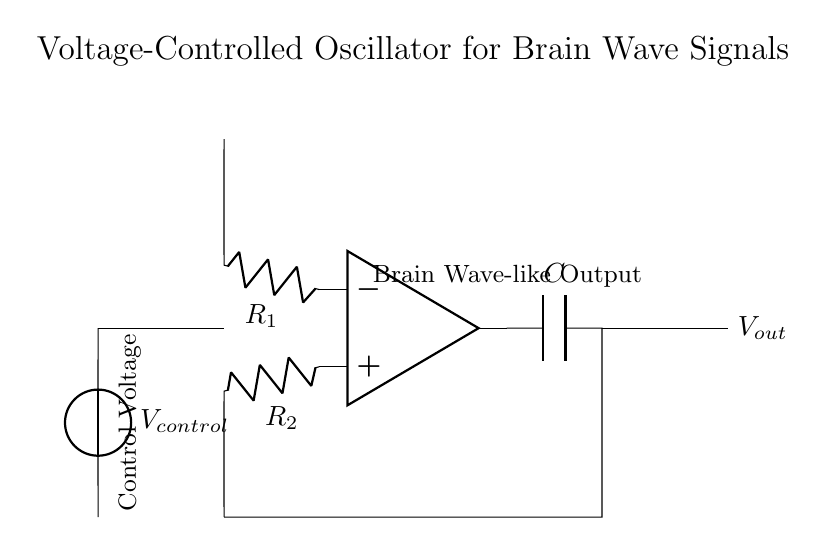What component is used to control the oscillator frequency? The component used to control the oscillator frequency is a voltage source labeled as V control. It directly influences the operation of the circuit.
Answer: V control What is the purpose of the capacitor in this circuit? The capacitor in this circuit, labeled as C, is used to store charge, which is critical for the oscillation process. It influences the time constant and frequency response of the oscillator.
Answer: Store charge Which component provides the output signal? The output signal is provided by the node where the capacitor connects to the circuit path leading to the labeled output V out.
Answer: V out What type of circuit is this voltage-controlled oscillator? This circuit is an analog circuit because it processes continuous voltage values as input and output signals representing brain wave-like frequencies.
Answer: Analog How many resistors are present in this circuit? There are two resistors present in the circuit, labeled as R1 and R2, which form part of the feedback mechanism for the operational amplifier.
Answer: Two What is the significance of the labeled brain wave-like output? The brain wave-like output indicates the specific type of signal this circuit is designed to generate, which is essential for applications in consciousness studies and neuroscience research.
Answer: Signal generation What role does the operational amplifier play in this circuit? The operational amplifier amplifies the input signals, enabling the circuit to produce oscillations based on the feedback network formed by the resistors and capacitor, critical for creating brain-like waveforms.
Answer: Signal amplification 